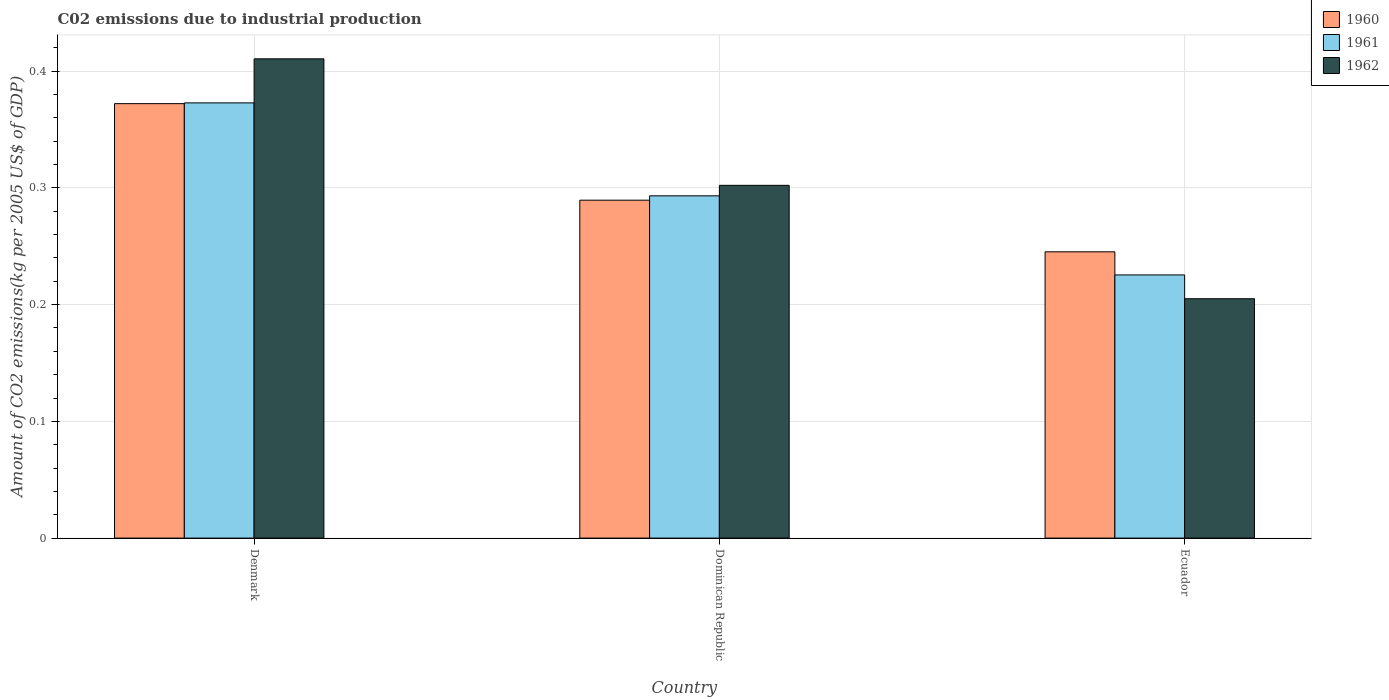How many bars are there on the 3rd tick from the right?
Keep it short and to the point. 3. What is the label of the 1st group of bars from the left?
Provide a short and direct response. Denmark. In how many cases, is the number of bars for a given country not equal to the number of legend labels?
Ensure brevity in your answer.  0. What is the amount of CO2 emitted due to industrial production in 1962 in Dominican Republic?
Make the answer very short. 0.3. Across all countries, what is the maximum amount of CO2 emitted due to industrial production in 1961?
Make the answer very short. 0.37. Across all countries, what is the minimum amount of CO2 emitted due to industrial production in 1962?
Your answer should be compact. 0.21. In which country was the amount of CO2 emitted due to industrial production in 1960 minimum?
Provide a short and direct response. Ecuador. What is the total amount of CO2 emitted due to industrial production in 1961 in the graph?
Provide a succinct answer. 0.89. What is the difference between the amount of CO2 emitted due to industrial production in 1962 in Denmark and that in Ecuador?
Give a very brief answer. 0.21. What is the difference between the amount of CO2 emitted due to industrial production in 1960 in Ecuador and the amount of CO2 emitted due to industrial production in 1962 in Dominican Republic?
Your response must be concise. -0.06. What is the average amount of CO2 emitted due to industrial production in 1961 per country?
Provide a succinct answer. 0.3. What is the difference between the amount of CO2 emitted due to industrial production of/in 1960 and amount of CO2 emitted due to industrial production of/in 1961 in Ecuador?
Provide a short and direct response. 0.02. What is the ratio of the amount of CO2 emitted due to industrial production in 1961 in Denmark to that in Ecuador?
Provide a short and direct response. 1.65. Is the amount of CO2 emitted due to industrial production in 1960 in Denmark less than that in Ecuador?
Ensure brevity in your answer.  No. Is the difference between the amount of CO2 emitted due to industrial production in 1960 in Denmark and Dominican Republic greater than the difference between the amount of CO2 emitted due to industrial production in 1961 in Denmark and Dominican Republic?
Ensure brevity in your answer.  Yes. What is the difference between the highest and the second highest amount of CO2 emitted due to industrial production in 1961?
Your answer should be very brief. 0.08. What is the difference between the highest and the lowest amount of CO2 emitted due to industrial production in 1961?
Give a very brief answer. 0.15. In how many countries, is the amount of CO2 emitted due to industrial production in 1961 greater than the average amount of CO2 emitted due to industrial production in 1961 taken over all countries?
Offer a very short reply. 1. What does the 1st bar from the left in Dominican Republic represents?
Offer a terse response. 1960. How many bars are there?
Your answer should be very brief. 9. Are all the bars in the graph horizontal?
Provide a succinct answer. No. Are the values on the major ticks of Y-axis written in scientific E-notation?
Keep it short and to the point. No. Does the graph contain grids?
Offer a terse response. Yes. How many legend labels are there?
Give a very brief answer. 3. How are the legend labels stacked?
Make the answer very short. Vertical. What is the title of the graph?
Provide a succinct answer. C02 emissions due to industrial production. Does "2008" appear as one of the legend labels in the graph?
Your answer should be very brief. No. What is the label or title of the Y-axis?
Provide a short and direct response. Amount of CO2 emissions(kg per 2005 US$ of GDP). What is the Amount of CO2 emissions(kg per 2005 US$ of GDP) in 1960 in Denmark?
Offer a terse response. 0.37. What is the Amount of CO2 emissions(kg per 2005 US$ of GDP) of 1961 in Denmark?
Offer a very short reply. 0.37. What is the Amount of CO2 emissions(kg per 2005 US$ of GDP) in 1962 in Denmark?
Offer a terse response. 0.41. What is the Amount of CO2 emissions(kg per 2005 US$ of GDP) in 1960 in Dominican Republic?
Provide a succinct answer. 0.29. What is the Amount of CO2 emissions(kg per 2005 US$ of GDP) of 1961 in Dominican Republic?
Provide a short and direct response. 0.29. What is the Amount of CO2 emissions(kg per 2005 US$ of GDP) in 1962 in Dominican Republic?
Keep it short and to the point. 0.3. What is the Amount of CO2 emissions(kg per 2005 US$ of GDP) of 1960 in Ecuador?
Your answer should be very brief. 0.25. What is the Amount of CO2 emissions(kg per 2005 US$ of GDP) in 1961 in Ecuador?
Provide a short and direct response. 0.23. What is the Amount of CO2 emissions(kg per 2005 US$ of GDP) of 1962 in Ecuador?
Your response must be concise. 0.21. Across all countries, what is the maximum Amount of CO2 emissions(kg per 2005 US$ of GDP) of 1960?
Make the answer very short. 0.37. Across all countries, what is the maximum Amount of CO2 emissions(kg per 2005 US$ of GDP) of 1961?
Make the answer very short. 0.37. Across all countries, what is the maximum Amount of CO2 emissions(kg per 2005 US$ of GDP) in 1962?
Provide a succinct answer. 0.41. Across all countries, what is the minimum Amount of CO2 emissions(kg per 2005 US$ of GDP) in 1960?
Your answer should be very brief. 0.25. Across all countries, what is the minimum Amount of CO2 emissions(kg per 2005 US$ of GDP) of 1961?
Offer a very short reply. 0.23. Across all countries, what is the minimum Amount of CO2 emissions(kg per 2005 US$ of GDP) of 1962?
Offer a very short reply. 0.21. What is the total Amount of CO2 emissions(kg per 2005 US$ of GDP) of 1960 in the graph?
Your answer should be compact. 0.91. What is the total Amount of CO2 emissions(kg per 2005 US$ of GDP) in 1961 in the graph?
Your response must be concise. 0.89. What is the total Amount of CO2 emissions(kg per 2005 US$ of GDP) of 1962 in the graph?
Provide a short and direct response. 0.92. What is the difference between the Amount of CO2 emissions(kg per 2005 US$ of GDP) of 1960 in Denmark and that in Dominican Republic?
Ensure brevity in your answer.  0.08. What is the difference between the Amount of CO2 emissions(kg per 2005 US$ of GDP) in 1961 in Denmark and that in Dominican Republic?
Provide a short and direct response. 0.08. What is the difference between the Amount of CO2 emissions(kg per 2005 US$ of GDP) in 1962 in Denmark and that in Dominican Republic?
Provide a succinct answer. 0.11. What is the difference between the Amount of CO2 emissions(kg per 2005 US$ of GDP) of 1960 in Denmark and that in Ecuador?
Your answer should be very brief. 0.13. What is the difference between the Amount of CO2 emissions(kg per 2005 US$ of GDP) of 1961 in Denmark and that in Ecuador?
Ensure brevity in your answer.  0.15. What is the difference between the Amount of CO2 emissions(kg per 2005 US$ of GDP) of 1962 in Denmark and that in Ecuador?
Your answer should be very brief. 0.21. What is the difference between the Amount of CO2 emissions(kg per 2005 US$ of GDP) in 1960 in Dominican Republic and that in Ecuador?
Keep it short and to the point. 0.04. What is the difference between the Amount of CO2 emissions(kg per 2005 US$ of GDP) in 1961 in Dominican Republic and that in Ecuador?
Ensure brevity in your answer.  0.07. What is the difference between the Amount of CO2 emissions(kg per 2005 US$ of GDP) of 1962 in Dominican Republic and that in Ecuador?
Your response must be concise. 0.1. What is the difference between the Amount of CO2 emissions(kg per 2005 US$ of GDP) in 1960 in Denmark and the Amount of CO2 emissions(kg per 2005 US$ of GDP) in 1961 in Dominican Republic?
Your response must be concise. 0.08. What is the difference between the Amount of CO2 emissions(kg per 2005 US$ of GDP) in 1960 in Denmark and the Amount of CO2 emissions(kg per 2005 US$ of GDP) in 1962 in Dominican Republic?
Your response must be concise. 0.07. What is the difference between the Amount of CO2 emissions(kg per 2005 US$ of GDP) of 1961 in Denmark and the Amount of CO2 emissions(kg per 2005 US$ of GDP) of 1962 in Dominican Republic?
Provide a short and direct response. 0.07. What is the difference between the Amount of CO2 emissions(kg per 2005 US$ of GDP) in 1960 in Denmark and the Amount of CO2 emissions(kg per 2005 US$ of GDP) in 1961 in Ecuador?
Keep it short and to the point. 0.15. What is the difference between the Amount of CO2 emissions(kg per 2005 US$ of GDP) of 1960 in Denmark and the Amount of CO2 emissions(kg per 2005 US$ of GDP) of 1962 in Ecuador?
Provide a succinct answer. 0.17. What is the difference between the Amount of CO2 emissions(kg per 2005 US$ of GDP) in 1961 in Denmark and the Amount of CO2 emissions(kg per 2005 US$ of GDP) in 1962 in Ecuador?
Provide a succinct answer. 0.17. What is the difference between the Amount of CO2 emissions(kg per 2005 US$ of GDP) of 1960 in Dominican Republic and the Amount of CO2 emissions(kg per 2005 US$ of GDP) of 1961 in Ecuador?
Give a very brief answer. 0.06. What is the difference between the Amount of CO2 emissions(kg per 2005 US$ of GDP) in 1960 in Dominican Republic and the Amount of CO2 emissions(kg per 2005 US$ of GDP) in 1962 in Ecuador?
Your answer should be compact. 0.08. What is the difference between the Amount of CO2 emissions(kg per 2005 US$ of GDP) in 1961 in Dominican Republic and the Amount of CO2 emissions(kg per 2005 US$ of GDP) in 1962 in Ecuador?
Your answer should be very brief. 0.09. What is the average Amount of CO2 emissions(kg per 2005 US$ of GDP) in 1960 per country?
Provide a short and direct response. 0.3. What is the average Amount of CO2 emissions(kg per 2005 US$ of GDP) of 1961 per country?
Make the answer very short. 0.3. What is the average Amount of CO2 emissions(kg per 2005 US$ of GDP) in 1962 per country?
Offer a very short reply. 0.31. What is the difference between the Amount of CO2 emissions(kg per 2005 US$ of GDP) of 1960 and Amount of CO2 emissions(kg per 2005 US$ of GDP) of 1961 in Denmark?
Provide a succinct answer. -0. What is the difference between the Amount of CO2 emissions(kg per 2005 US$ of GDP) in 1960 and Amount of CO2 emissions(kg per 2005 US$ of GDP) in 1962 in Denmark?
Your answer should be very brief. -0.04. What is the difference between the Amount of CO2 emissions(kg per 2005 US$ of GDP) in 1961 and Amount of CO2 emissions(kg per 2005 US$ of GDP) in 1962 in Denmark?
Offer a terse response. -0.04. What is the difference between the Amount of CO2 emissions(kg per 2005 US$ of GDP) in 1960 and Amount of CO2 emissions(kg per 2005 US$ of GDP) in 1961 in Dominican Republic?
Offer a very short reply. -0. What is the difference between the Amount of CO2 emissions(kg per 2005 US$ of GDP) in 1960 and Amount of CO2 emissions(kg per 2005 US$ of GDP) in 1962 in Dominican Republic?
Offer a very short reply. -0.01. What is the difference between the Amount of CO2 emissions(kg per 2005 US$ of GDP) in 1961 and Amount of CO2 emissions(kg per 2005 US$ of GDP) in 1962 in Dominican Republic?
Your response must be concise. -0.01. What is the difference between the Amount of CO2 emissions(kg per 2005 US$ of GDP) of 1960 and Amount of CO2 emissions(kg per 2005 US$ of GDP) of 1961 in Ecuador?
Your response must be concise. 0.02. What is the difference between the Amount of CO2 emissions(kg per 2005 US$ of GDP) of 1960 and Amount of CO2 emissions(kg per 2005 US$ of GDP) of 1962 in Ecuador?
Offer a very short reply. 0.04. What is the difference between the Amount of CO2 emissions(kg per 2005 US$ of GDP) of 1961 and Amount of CO2 emissions(kg per 2005 US$ of GDP) of 1962 in Ecuador?
Your answer should be compact. 0.02. What is the ratio of the Amount of CO2 emissions(kg per 2005 US$ of GDP) in 1961 in Denmark to that in Dominican Republic?
Ensure brevity in your answer.  1.27. What is the ratio of the Amount of CO2 emissions(kg per 2005 US$ of GDP) in 1962 in Denmark to that in Dominican Republic?
Provide a succinct answer. 1.36. What is the ratio of the Amount of CO2 emissions(kg per 2005 US$ of GDP) in 1960 in Denmark to that in Ecuador?
Ensure brevity in your answer.  1.52. What is the ratio of the Amount of CO2 emissions(kg per 2005 US$ of GDP) of 1961 in Denmark to that in Ecuador?
Give a very brief answer. 1.65. What is the ratio of the Amount of CO2 emissions(kg per 2005 US$ of GDP) in 1962 in Denmark to that in Ecuador?
Your answer should be very brief. 2. What is the ratio of the Amount of CO2 emissions(kg per 2005 US$ of GDP) of 1960 in Dominican Republic to that in Ecuador?
Make the answer very short. 1.18. What is the ratio of the Amount of CO2 emissions(kg per 2005 US$ of GDP) in 1961 in Dominican Republic to that in Ecuador?
Keep it short and to the point. 1.3. What is the ratio of the Amount of CO2 emissions(kg per 2005 US$ of GDP) in 1962 in Dominican Republic to that in Ecuador?
Keep it short and to the point. 1.47. What is the difference between the highest and the second highest Amount of CO2 emissions(kg per 2005 US$ of GDP) of 1960?
Provide a succinct answer. 0.08. What is the difference between the highest and the second highest Amount of CO2 emissions(kg per 2005 US$ of GDP) of 1961?
Keep it short and to the point. 0.08. What is the difference between the highest and the second highest Amount of CO2 emissions(kg per 2005 US$ of GDP) in 1962?
Offer a terse response. 0.11. What is the difference between the highest and the lowest Amount of CO2 emissions(kg per 2005 US$ of GDP) in 1960?
Ensure brevity in your answer.  0.13. What is the difference between the highest and the lowest Amount of CO2 emissions(kg per 2005 US$ of GDP) in 1961?
Your answer should be very brief. 0.15. What is the difference between the highest and the lowest Amount of CO2 emissions(kg per 2005 US$ of GDP) of 1962?
Make the answer very short. 0.21. 